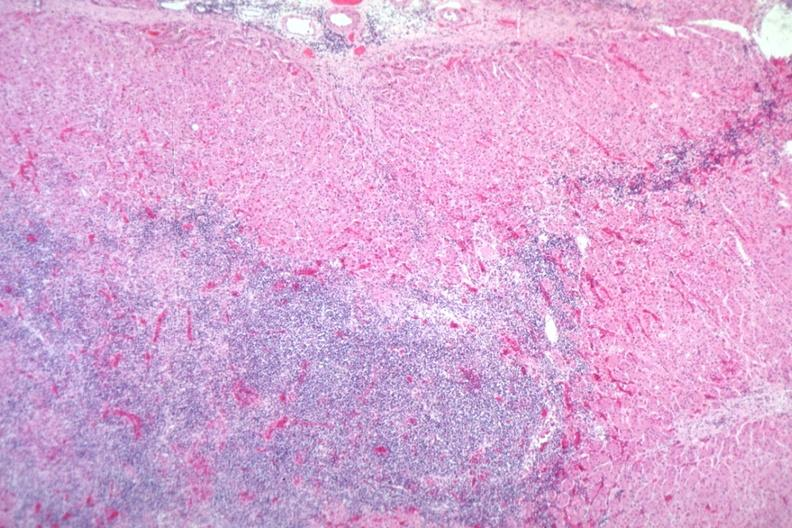what does this image show?
Answer the question using a single word or phrase. Easily seen infiltrate 